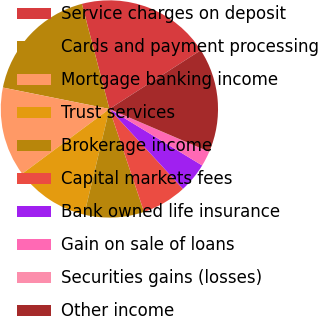<chart> <loc_0><loc_0><loc_500><loc_500><pie_chart><fcel>Service charges on deposit<fcel>Cards and payment processing<fcel>Mortgage banking income<fcel>Trust services<fcel>Brokerage income<fcel>Capital markets fees<fcel>Bank owned life insurance<fcel>Gain on sale of loans<fcel>Securities gains (losses)<fcel>Other income<nl><fcel>19.98%<fcel>17.77%<fcel>13.33%<fcel>11.11%<fcel>8.89%<fcel>6.67%<fcel>4.45%<fcel>2.23%<fcel>0.02%<fcel>15.55%<nl></chart> 